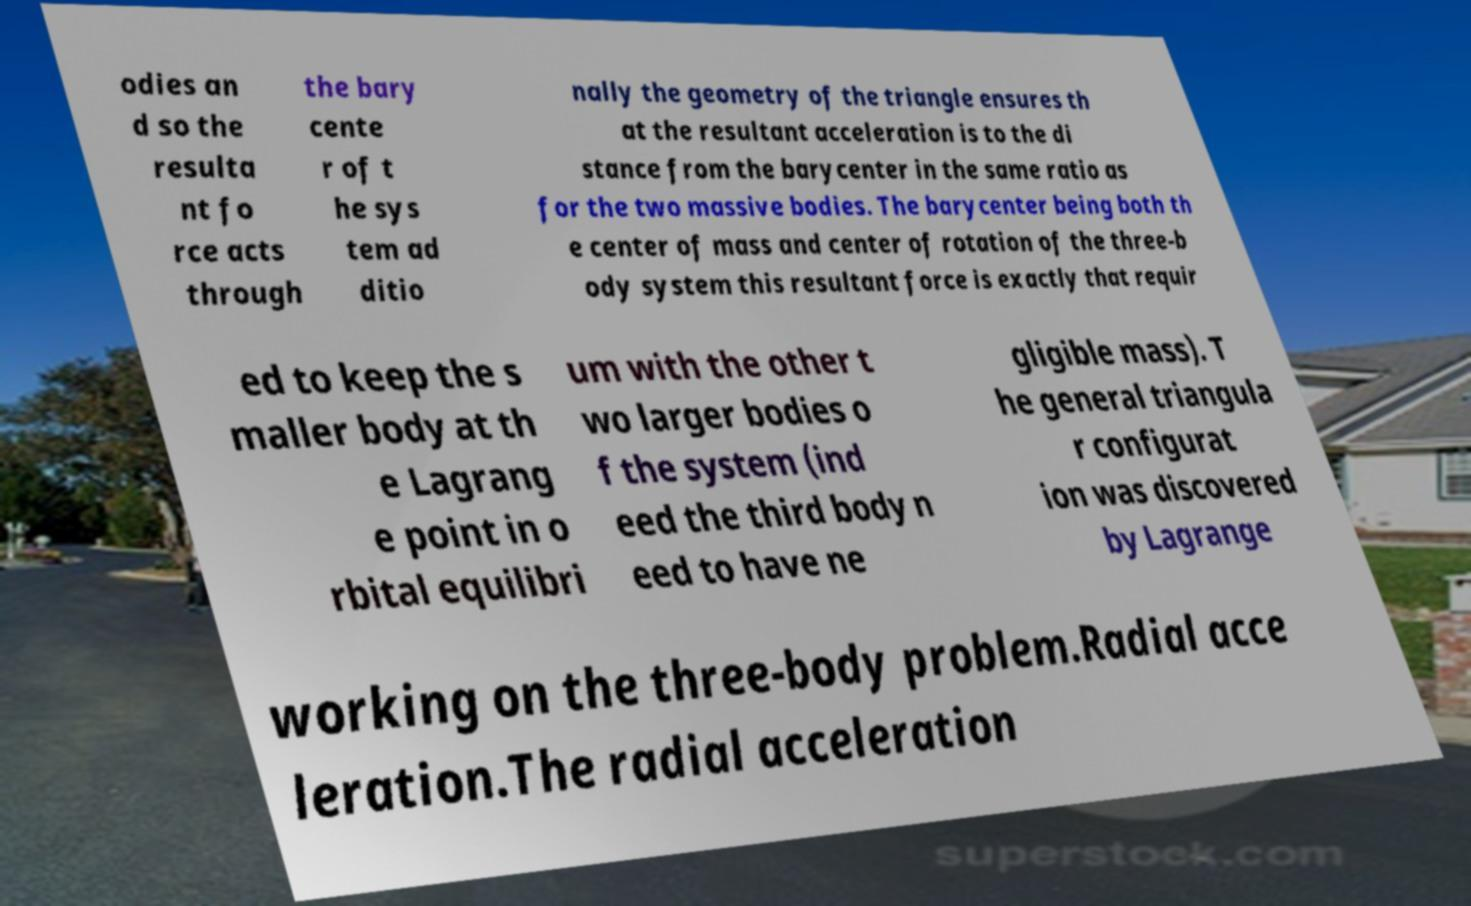Could you assist in decoding the text presented in this image and type it out clearly? odies an d so the resulta nt fo rce acts through the bary cente r of t he sys tem ad ditio nally the geometry of the triangle ensures th at the resultant acceleration is to the di stance from the barycenter in the same ratio as for the two massive bodies. The barycenter being both th e center of mass and center of rotation of the three-b ody system this resultant force is exactly that requir ed to keep the s maller body at th e Lagrang e point in o rbital equilibri um with the other t wo larger bodies o f the system (ind eed the third body n eed to have ne gligible mass). T he general triangula r configurat ion was discovered by Lagrange working on the three-body problem.Radial acce leration.The radial acceleration 